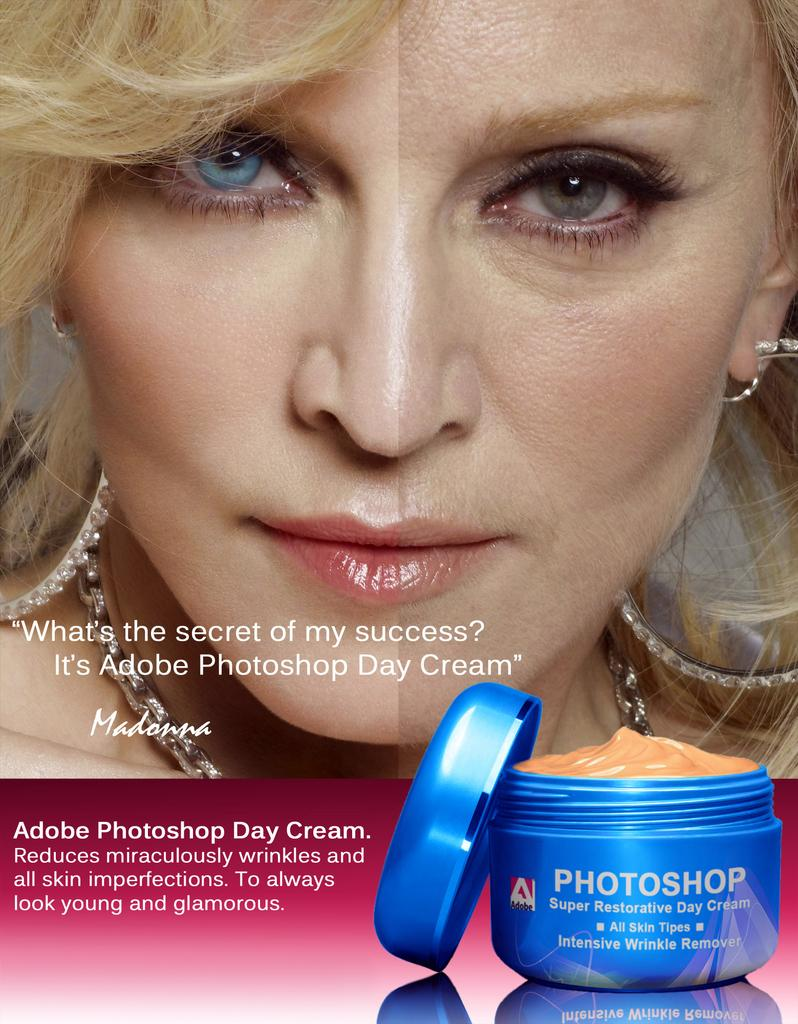<image>
Provide a brief description of the given image. Ad showing a woman's face behind a blue cream that says "Photoshop". 